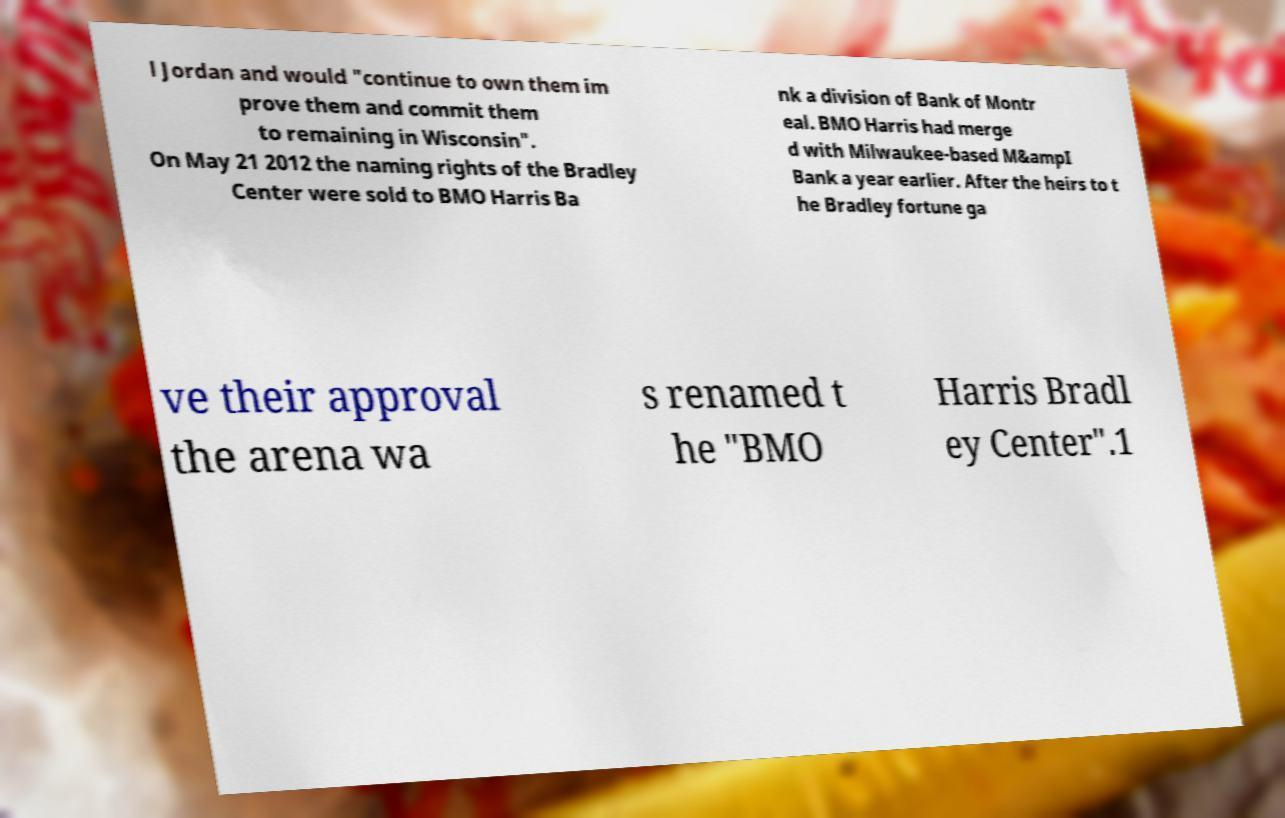Please read and relay the text visible in this image. What does it say? l Jordan and would "continue to own them im prove them and commit them to remaining in Wisconsin". On May 21 2012 the naming rights of the Bradley Center were sold to BMO Harris Ba nk a division of Bank of Montr eal. BMO Harris had merge d with Milwaukee-based M&ampI Bank a year earlier. After the heirs to t he Bradley fortune ga ve their approval the arena wa s renamed t he "BMO Harris Bradl ey Center".1 